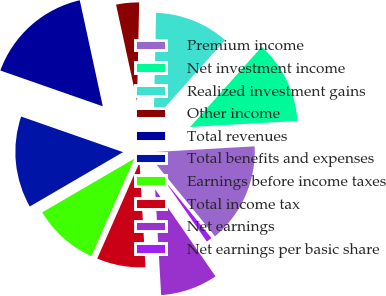<chart> <loc_0><loc_0><loc_500><loc_500><pie_chart><fcel>Premium income<fcel>Net investment income<fcel>Realized investment gains<fcel>Other income<fcel>Total revenues<fcel>Total benefits and expenses<fcel>Earnings before income taxes<fcel>Total income tax<fcel>Net earnings<fcel>Net earnings per basic share<nl><fcel>15.0%<fcel>12.5%<fcel>11.25%<fcel>3.75%<fcel>16.25%<fcel>13.75%<fcel>10.0%<fcel>7.5%<fcel>8.75%<fcel>1.25%<nl></chart> 